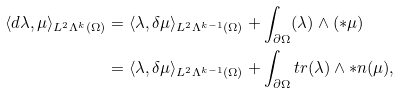Convert formula to latex. <formula><loc_0><loc_0><loc_500><loc_500>\langle d \lambda , \mu \rangle _ { L ^ { 2 } \Lambda ^ { k } ( \Omega ) } & = \langle \lambda , \delta \mu \rangle _ { L ^ { 2 } \Lambda ^ { k - 1 } ( \Omega ) } + \int _ { \partial \Omega } ( \lambda ) \wedge ( \ast \mu ) \\ & = \langle \lambda , \delta \mu \rangle _ { L ^ { 2 } \Lambda ^ { k - 1 } ( \Omega ) } + \int _ { \partial \Omega } t r ( \lambda ) \wedge \ast n ( \mu ) ,</formula> 